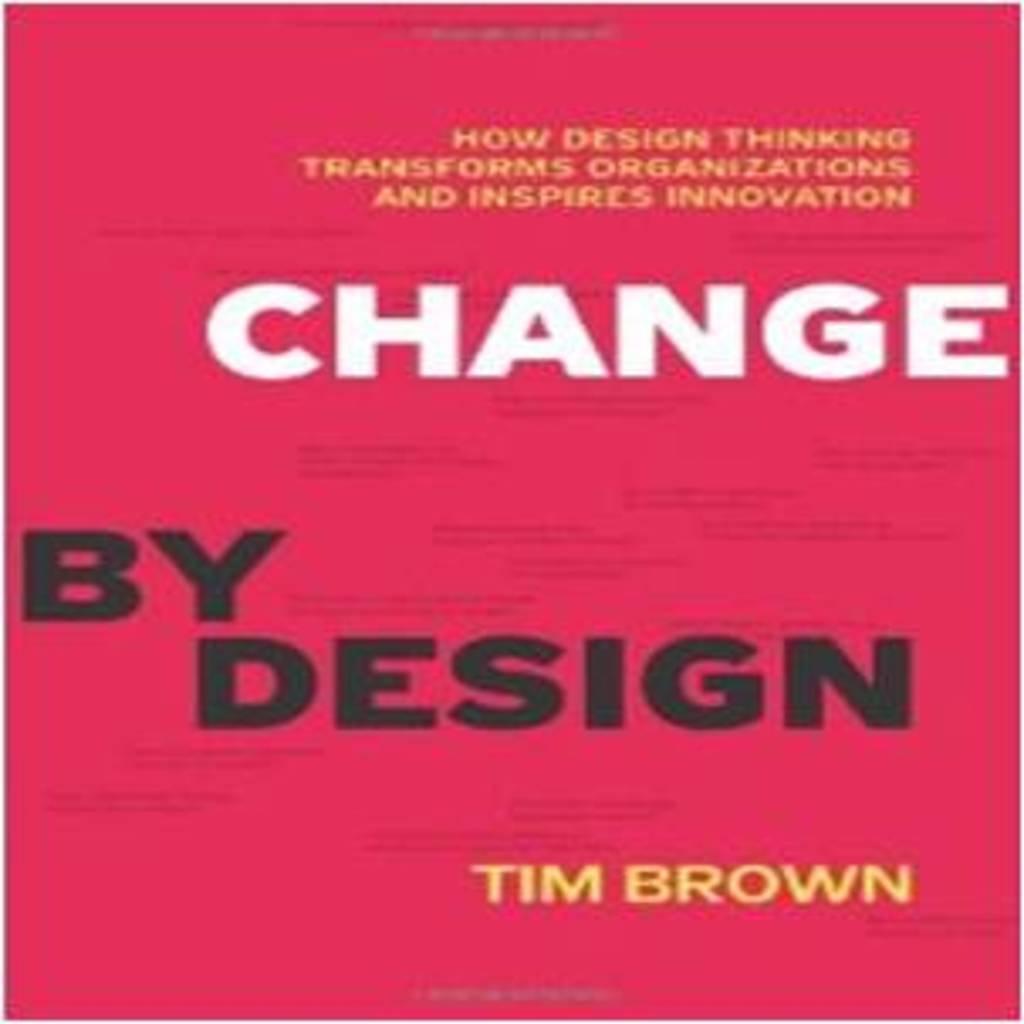What does the white text say?
Your response must be concise. Change. 